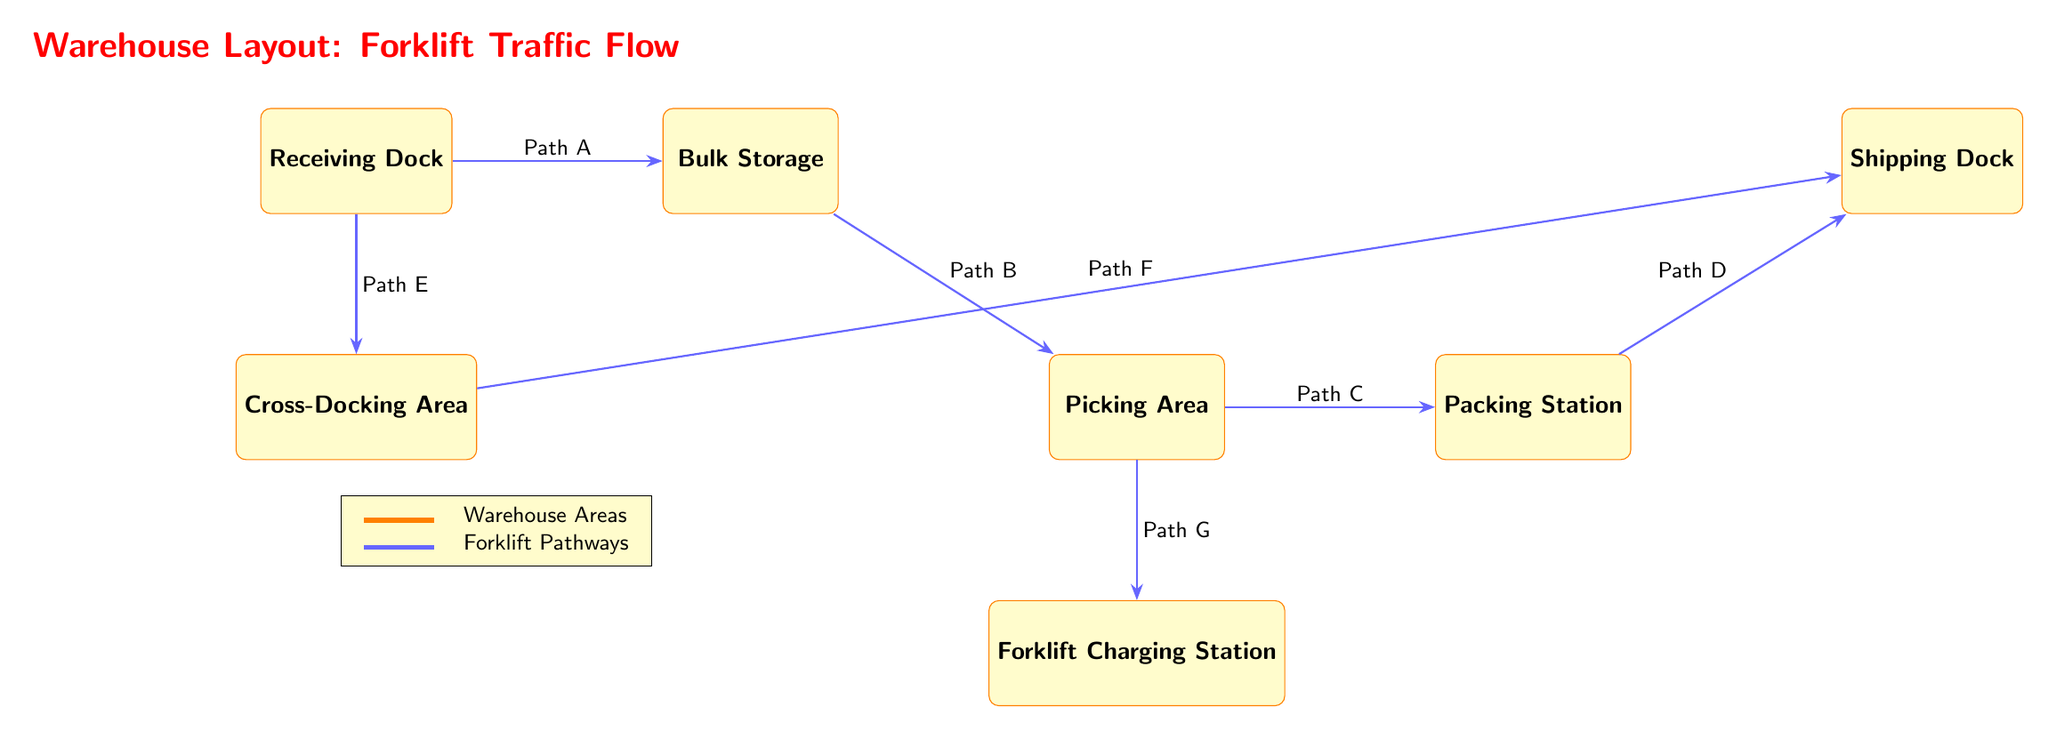What is the first node in the diagram? The first node in the diagram represents the "Receiving Dock," which is the starting point of the forklift traffic flow in the warehouse layout.
Answer: Receiving Dock How many pathways are indicated in the diagram? The diagram features a total of seven pathways labeled A through G, connecting various warehouse areas and facilitating forklift traffic.
Answer: 7 Which area is located directly below the Receiving Dock? The area directly below the Receiving Dock is the "Cross-Docking Area," as indicated by its position in the layout.
Answer: Cross-Docking Area What is the last node before the Shipping Dock? The last node before the Shipping Dock is the "Packing Station," which is the final area in the flow leading to shipping.
Answer: Packing Station Which pathway connects the Picking Area to the Forklift Charging Station? The pathway that connects the Picking Area to the Forklift Charging Station is labeled as "Path G," indicating the route the forklift takes.
Answer: Path G What are the two nodes that are adjacent to the Bulk Storage? The two nodes adjacent to the Bulk Storage are the "Receiving Dock" on the left and the "Picking Area" below it, forming a connection in the layout.
Answer: Receiving Dock, Picking Area How does a forklift move from the Cross-Docking Area to the Shipping Dock? A forklift moves from the Cross-Docking Area to the Shipping Dock via "Path F," showing the direct pathway for efficient traffic flow.
Answer: Path F How many total warehouse areas are represented in the diagram? The diagram illustrates a total of seven warehouse areas, showing different functional zones within the layout.
Answer: 7 What type of diagram is this and what does it illustrate? This is a textbook diagram that illustrates "Warehouse Layout Efficiency with Forklift Traffic Flow and Optimal Pathways," highlighting the spatial arrangement and pathways within the warehouse.
Answer: Textbook Diagram 